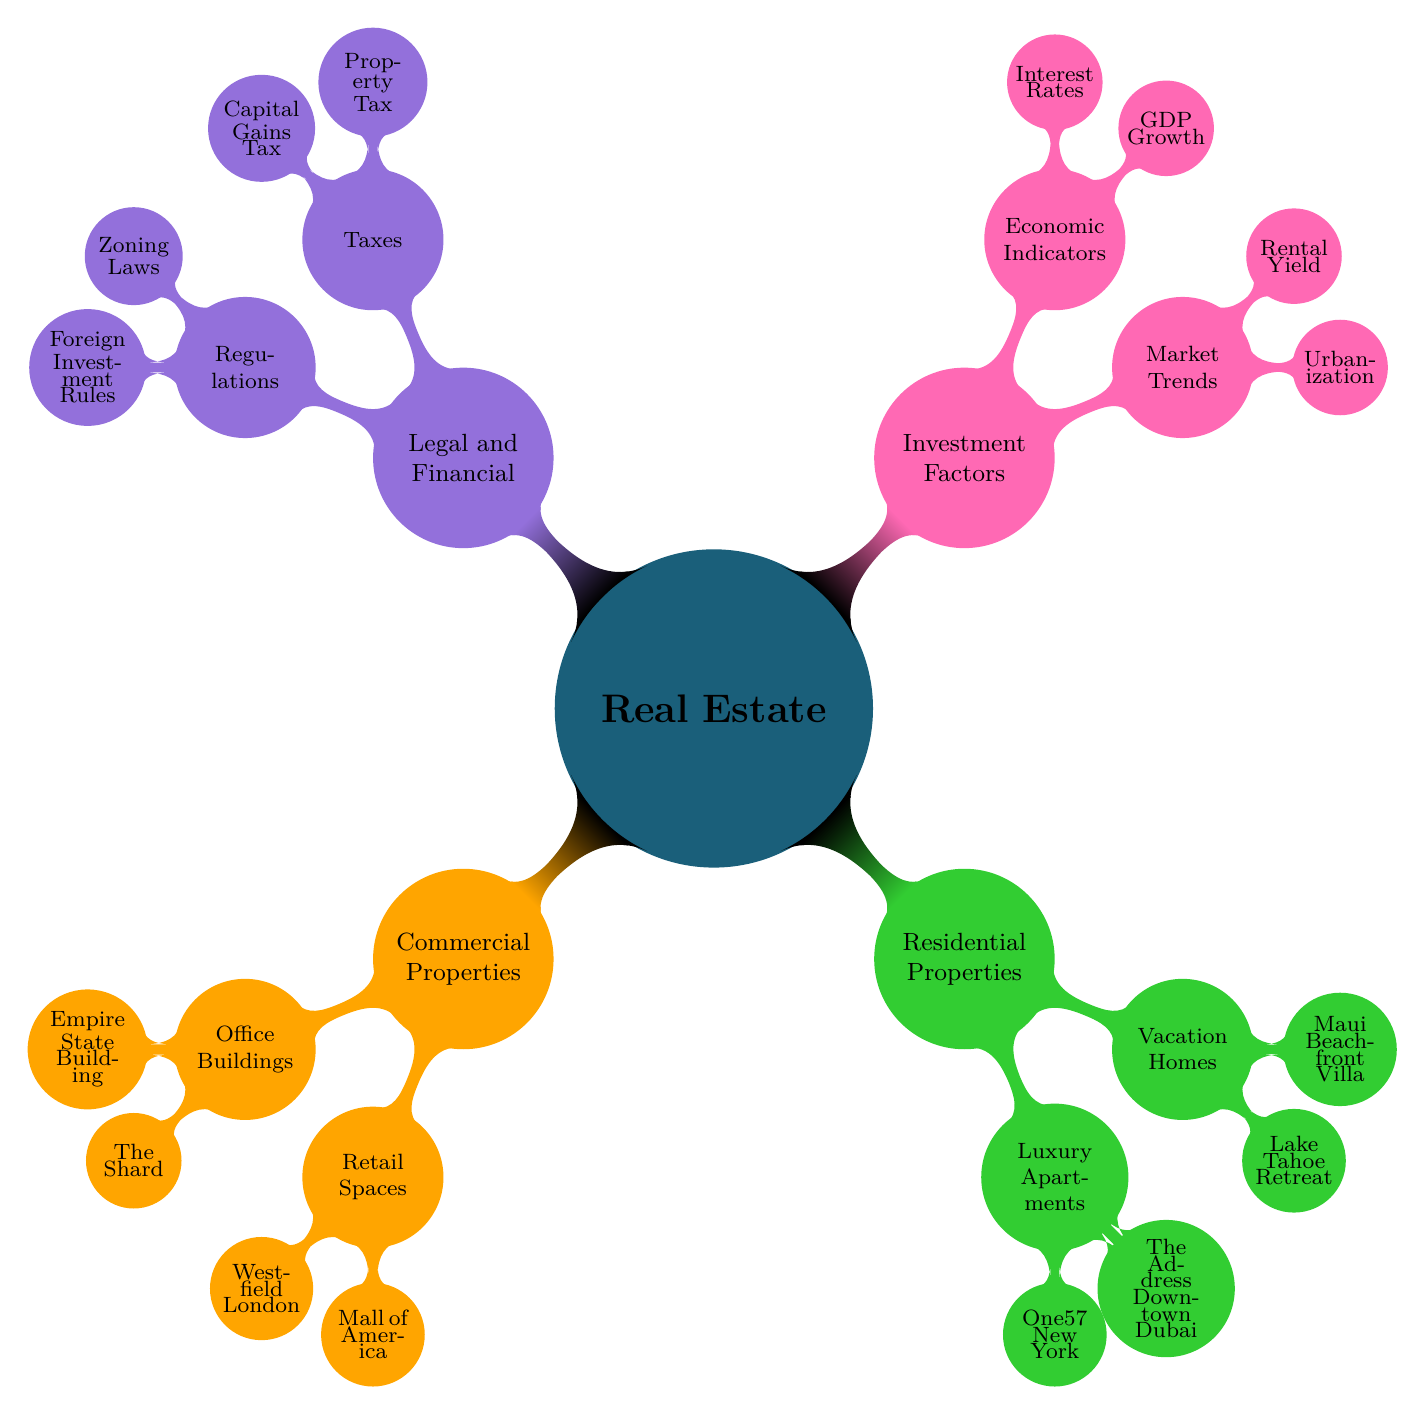What are examples of commercial properties? The diagram shows two main categories under "Commercial Properties": Office Buildings and Retail Spaces. Under Office Buildings, it lists "Empire State Building" and "The Shard." Under Retail Spaces, it lists "Westfield London" and "Mall of America."
Answer: Empire State Building, The Shard, Westfield London, Mall of America How many types of residential properties are listed? The diagram includes one main category called "Residential Properties" which has two child nodes: Luxury Apartments and Vacation Homes. Therefore, there are two types of residential properties listed.
Answer: 2 What economic indicator is mentioned in the investment factors? Looking at the section "Investment Factors," the second subcategory is "Economic Indicators," which lists two indicators: "GDP Growth" and "Interest Rates." Therefore, one indicator mentioned is "GDP Growth."
Answer: GDP Growth Which luxury apartment is located in New York? Under the "Residential Properties" category, the node "Luxury Apartments" lists two examples: "One57 New York" and "The Address Downtown Dubai." The one located in New York is "One57 New York."
Answer: One57 New York What do zoning laws relate to in the diagram? The "Legal and Financial" category contains two subcategories: "Taxes" and "Regulations." "Zoning Laws" is listed under "Regulations." This indicates that zoning laws relate to the regulations governing property use and development.
Answer: Regulations What is the relationship between rental yield and market trends? In the "Investment Factors" category, the subcategory "Market Trends" has "Rental Yield" as one of its entries. This implies that rental yield is a factor influencing market trends in real estate.
Answer: Market Trends What type of investment factor is urbanization classified under? Under "Investment Factors," the first subcategory is "Market Trends," and "Urbanization" is listed there. This shows that urbanization is classified under market trends as a factor impacting investment.
Answer: Market Trends What are the two types of taxes listed in the diagram? The section on "Legal and Financial" contains a subcategory called "Taxes," which lists "Property Tax" and "Capital Gains Tax." These two types of taxes are directly shown in the diagram.
Answer: Property Tax, Capital Gains Tax 